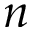<formula> <loc_0><loc_0><loc_500><loc_500>n</formula> 